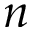<formula> <loc_0><loc_0><loc_500><loc_500>n</formula> 